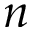<formula> <loc_0><loc_0><loc_500><loc_500>n</formula> 